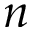<formula> <loc_0><loc_0><loc_500><loc_500>n</formula> 